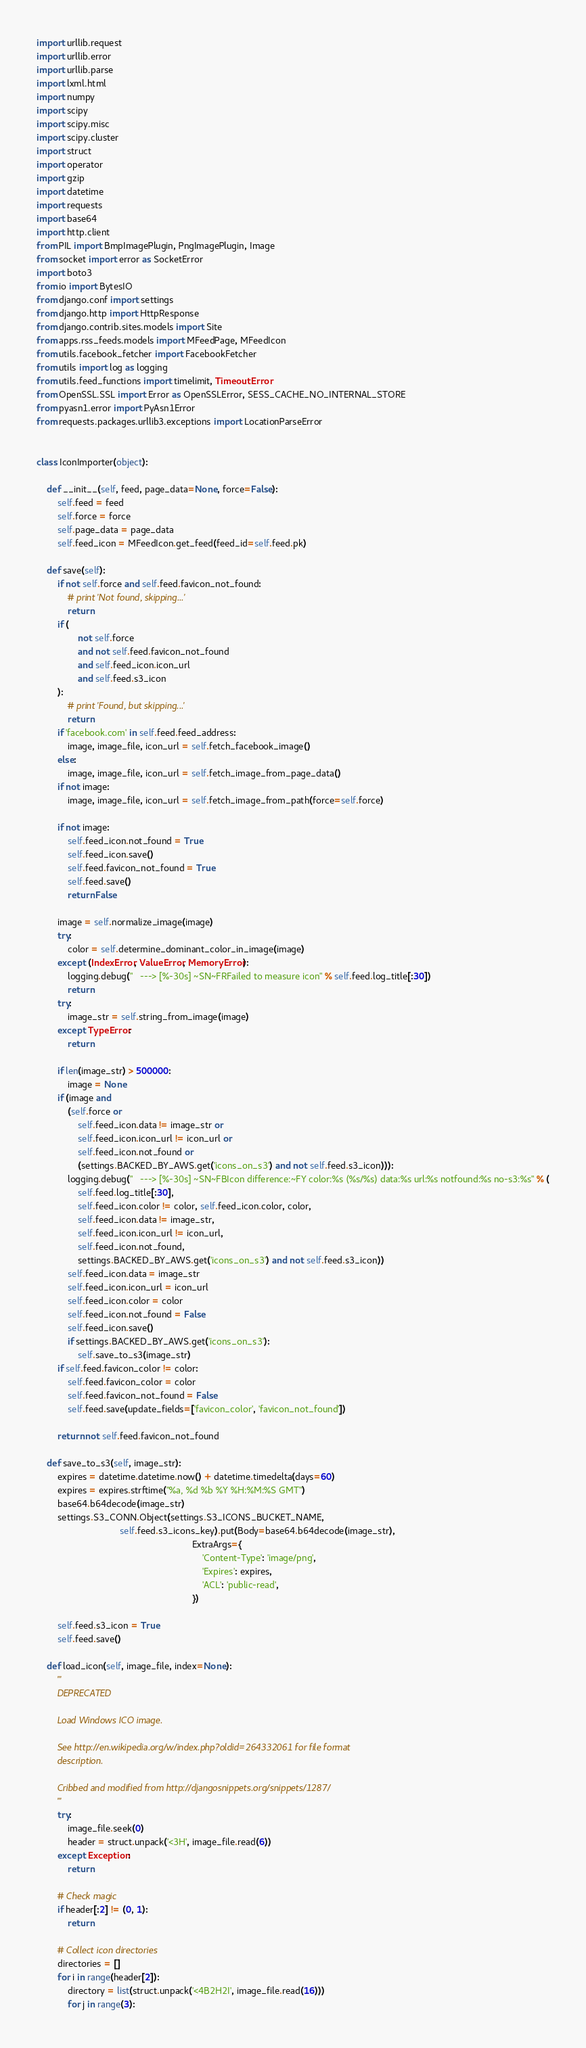<code> <loc_0><loc_0><loc_500><loc_500><_Python_>import urllib.request
import urllib.error
import urllib.parse
import lxml.html
import numpy
import scipy
import scipy.misc
import scipy.cluster
import struct
import operator
import gzip
import datetime
import requests
import base64
import http.client
from PIL import BmpImagePlugin, PngImagePlugin, Image
from socket import error as SocketError
import boto3
from io import BytesIO
from django.conf import settings
from django.http import HttpResponse
from django.contrib.sites.models import Site
from apps.rss_feeds.models import MFeedPage, MFeedIcon
from utils.facebook_fetcher import FacebookFetcher
from utils import log as logging
from utils.feed_functions import timelimit, TimeoutError
from OpenSSL.SSL import Error as OpenSSLError, SESS_CACHE_NO_INTERNAL_STORE
from pyasn1.error import PyAsn1Error
from requests.packages.urllib3.exceptions import LocationParseError


class IconImporter(object):

    def __init__(self, feed, page_data=None, force=False):
        self.feed = feed
        self.force = force
        self.page_data = page_data
        self.feed_icon = MFeedIcon.get_feed(feed_id=self.feed.pk)

    def save(self):
        if not self.force and self.feed.favicon_not_found:
            # print 'Not found, skipping...'
            return
        if (
                not self.force
                and not self.feed.favicon_not_found
                and self.feed_icon.icon_url
                and self.feed.s3_icon
        ):
            # print 'Found, but skipping...'
            return
        if 'facebook.com' in self.feed.feed_address:
            image, image_file, icon_url = self.fetch_facebook_image()
        else:
            image, image_file, icon_url = self.fetch_image_from_page_data()
        if not image:
            image, image_file, icon_url = self.fetch_image_from_path(force=self.force)
        
        if not image:
            self.feed_icon.not_found = True
            self.feed_icon.save()
            self.feed.favicon_not_found = True
            self.feed.save()
            return False
        
        image = self.normalize_image(image)
        try:
            color = self.determine_dominant_color_in_image(image)
        except (IndexError, ValueError, MemoryError):
            logging.debug("   ---> [%-30s] ~SN~FRFailed to measure icon" % self.feed.log_title[:30])
            return
        try:
            image_str = self.string_from_image(image)
        except TypeError:
            return

        if len(image_str) > 500000:
            image = None
        if (image and
            (self.force or
                self.feed_icon.data != image_str or
                self.feed_icon.icon_url != icon_url or
                self.feed_icon.not_found or
                (settings.BACKED_BY_AWS.get('icons_on_s3') and not self.feed.s3_icon))):
            logging.debug("   ---> [%-30s] ~SN~FBIcon difference:~FY color:%s (%s/%s) data:%s url:%s notfound:%s no-s3:%s" % (
                self.feed.log_title[:30],
                self.feed_icon.color != color, self.feed_icon.color, color,
                self.feed_icon.data != image_str,
                self.feed_icon.icon_url != icon_url,
                self.feed_icon.not_found,
                settings.BACKED_BY_AWS.get('icons_on_s3') and not self.feed.s3_icon))
            self.feed_icon.data = image_str
            self.feed_icon.icon_url = icon_url
            self.feed_icon.color = color
            self.feed_icon.not_found = False
            self.feed_icon.save()
            if settings.BACKED_BY_AWS.get('icons_on_s3'):
                self.save_to_s3(image_str)
        if self.feed.favicon_color != color:
            self.feed.favicon_color = color
            self.feed.favicon_not_found = False
            self.feed.save(update_fields=['favicon_color', 'favicon_not_found'])
            
        return not self.feed.favicon_not_found

    def save_to_s3(self, image_str):
        expires = datetime.datetime.now() + datetime.timedelta(days=60)
        expires = expires.strftime("%a, %d %b %Y %H:%M:%S GMT")
        base64.b64decode(image_str)
        settings.S3_CONN.Object(settings.S3_ICONS_BUCKET_NAME, 
                                self.feed.s3_icons_key).put(Body=base64.b64decode(image_str), 
                                                            ExtraArgs={
                                                                'Content-Type': 'image/png',
                                                                'Expires': expires,
                                                                'ACL': 'public-read',
                                                            })

        self.feed.s3_icon = True
        self.feed.save()

    def load_icon(self, image_file, index=None):
        '''
        DEPRECATED

        Load Windows ICO image.

        See http://en.wikipedia.org/w/index.php?oldid=264332061 for file format
        description.

        Cribbed and modified from http://djangosnippets.org/snippets/1287/
        '''
        try:
            image_file.seek(0)
            header = struct.unpack('<3H', image_file.read(6))
        except Exception:
            return

        # Check magic
        if header[:2] != (0, 1):
            return

        # Collect icon directories
        directories = []
        for i in range(header[2]):
            directory = list(struct.unpack('<4B2H2I', image_file.read(16)))
            for j in range(3):</code> 